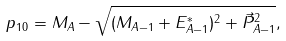Convert formula to latex. <formula><loc_0><loc_0><loc_500><loc_500>p _ { 1 0 } = M _ { A } - \sqrt { ( M _ { A - 1 } + E _ { A - 1 } ^ { * } ) ^ { 2 } + \vec { P } _ { A - 1 } ^ { 2 } } ,</formula> 